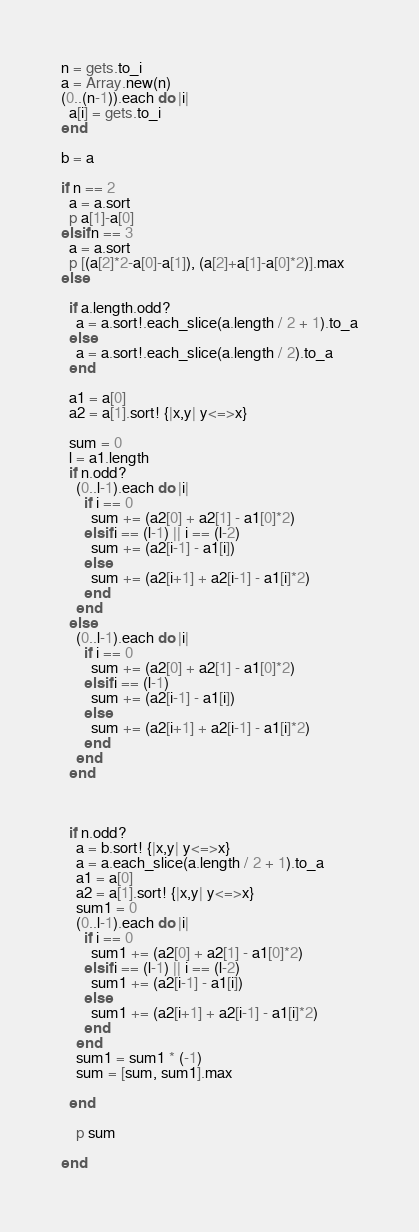<code> <loc_0><loc_0><loc_500><loc_500><_Ruby_>n = gets.to_i
a = Array.new(n)
(0..(n-1)).each do |i|
  a[i] = gets.to_i
end

b = a

if n == 2
  a = a.sort
  p a[1]-a[0]
elsif n == 3
  a = a.sort
  p [(a[2]*2-a[0]-a[1]), (a[2]+a[1]-a[0]*2)].max
else

  if a.length.odd?
    a = a.sort!.each_slice(a.length / 2 + 1).to_a
  else
    a = a.sort!.each_slice(a.length / 2).to_a
  end

  a1 = a[0]
  a2 = a[1].sort! {|x,y| y<=>x}

  sum = 0
  l = a1.length
  if n.odd?
    (0..l-1).each do |i|
      if i == 0
        sum += (a2[0] + a2[1] - a1[0]*2)
      elsif i == (l-1) || i == (l-2)
        sum += (a2[i-1] - a1[i])
      else
        sum += (a2[i+1] + a2[i-1] - a1[i]*2)
      end
    end
  else
    (0..l-1).each do |i|
      if i == 0
        sum += (a2[0] + a2[1] - a1[0]*2)
      elsif i == (l-1)
        sum += (a2[i-1] - a1[i])
      else
        sum += (a2[i+1] + a2[i-1] - a1[i]*2)
      end
    end
  end



  if n.odd?
    a = b.sort! {|x,y| y<=>x}
    a = a.each_slice(a.length / 2 + 1).to_a
    a1 = a[0]
    a2 = a[1].sort! {|x,y| y<=>x}
    sum1 = 0
    (0..l-1).each do |i|
      if i == 0
        sum1 += (a2[0] + a2[1] - a1[0]*2)
      elsif i == (l-1) || i == (l-2)
        sum1 += (a2[i-1] - a1[i])
      else
        sum1 += (a2[i+1] + a2[i-1] - a1[i]*2)
      end
    end
    sum1 = sum1 * (-1)
    sum = [sum, sum1].max

  end

    p sum

end
</code> 